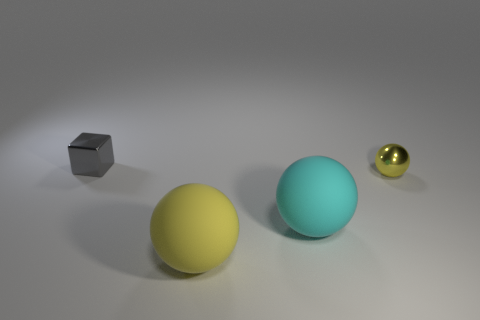What can be inferred about the texture and material of the objects? The surfaces of the spheres seem to have a smooth texture and a slight sheen, suggesting they might be made of a matte plastic or painted material. The cube, however, has a metallic luster, indicating it is likely made of metal. 